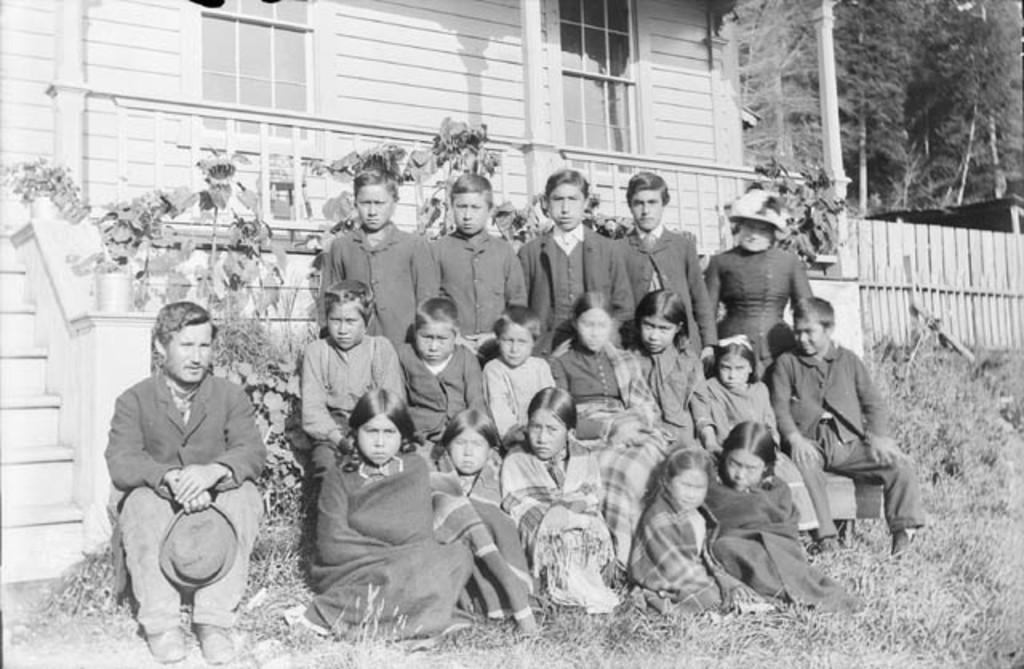How many people are in the image? There is a group of people in the image, but the exact number is not specified. What are the people in the image doing? Some people are sitting, while others are standing. What can be seen in the background of the image? There is a building and trees in the background of the image. What is the color scheme of the image? The image is in black and white. Can you see a goose swimming in the water near the trees in the image? There is no water or goose present in the image; it features a group of people with a background of a building and trees. How many goldfish are swimming in the bowl on the table in the image? There is no bowl or goldfish present in the image; it is a black and white image of a group of people with a background of a building and trees. 